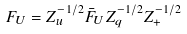Convert formula to latex. <formula><loc_0><loc_0><loc_500><loc_500>F _ { U } = Z ^ { - 1 / 2 } _ { u } \bar { F } _ { U } Z ^ { - 1 / 2 } _ { q } Z ^ { - 1 / 2 } _ { + }</formula> 